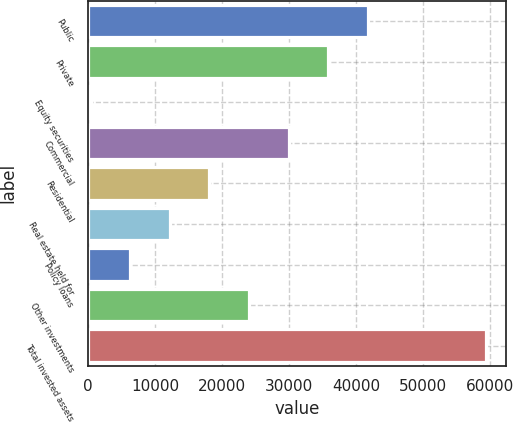Convert chart. <chart><loc_0><loc_0><loc_500><loc_500><bar_chart><fcel>Public<fcel>Private<fcel>Equity securities<fcel>Commercial<fcel>Residential<fcel>Real estate held for<fcel>Policy loans<fcel>Other investments<fcel>Total invested assets<nl><fcel>41772.9<fcel>35860.9<fcel>388.8<fcel>29948.8<fcel>18124.8<fcel>12212.8<fcel>6300.81<fcel>24036.8<fcel>59508.9<nl></chart> 